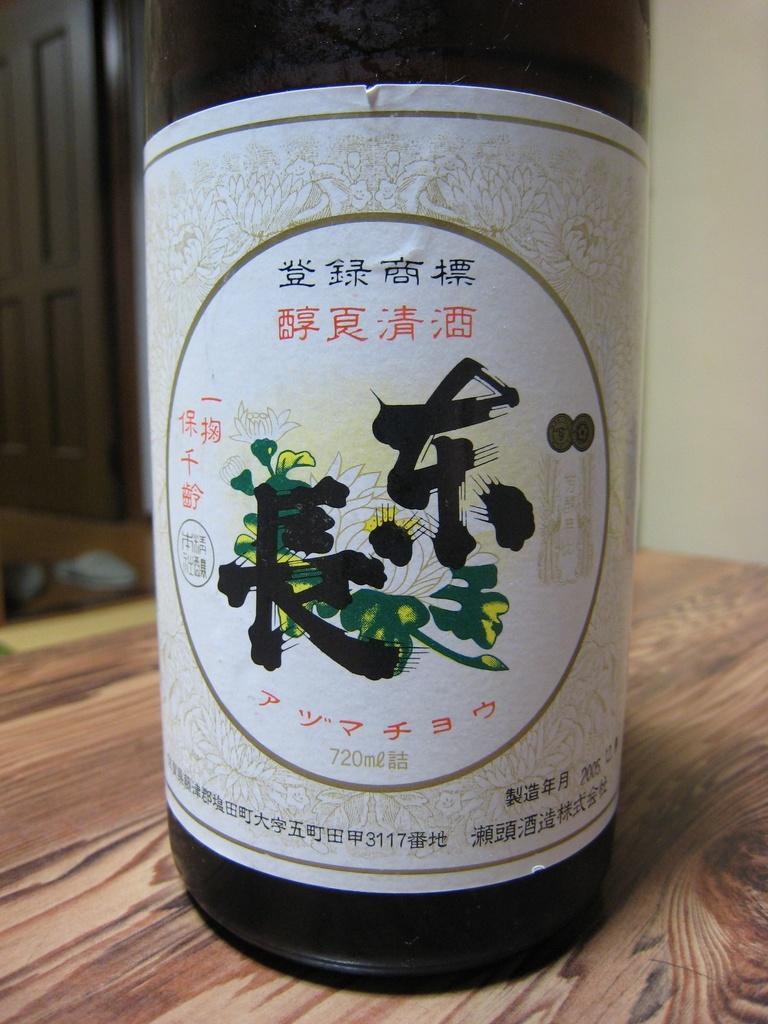In one or two sentences, can you explain what this image depicts? There is a bottle in the foreground area of the image on a wooden surface, there is a door and an object in the background. 